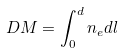Convert formula to latex. <formula><loc_0><loc_0><loc_500><loc_500>D M = \int _ { 0 } ^ { d } n _ { e } d l</formula> 